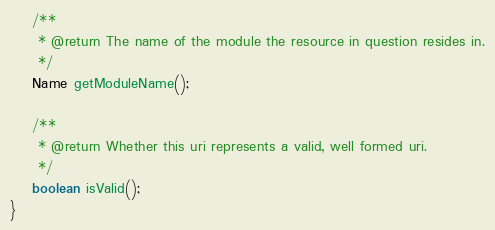Convert code to text. <code><loc_0><loc_0><loc_500><loc_500><_Java_>
    /**
     * @return The name of the module the resource in question resides in.
     */
    Name getModuleName();

    /**
     * @return Whether this uri represents a valid, well formed uri.
     */
    boolean isValid();
}
</code> 